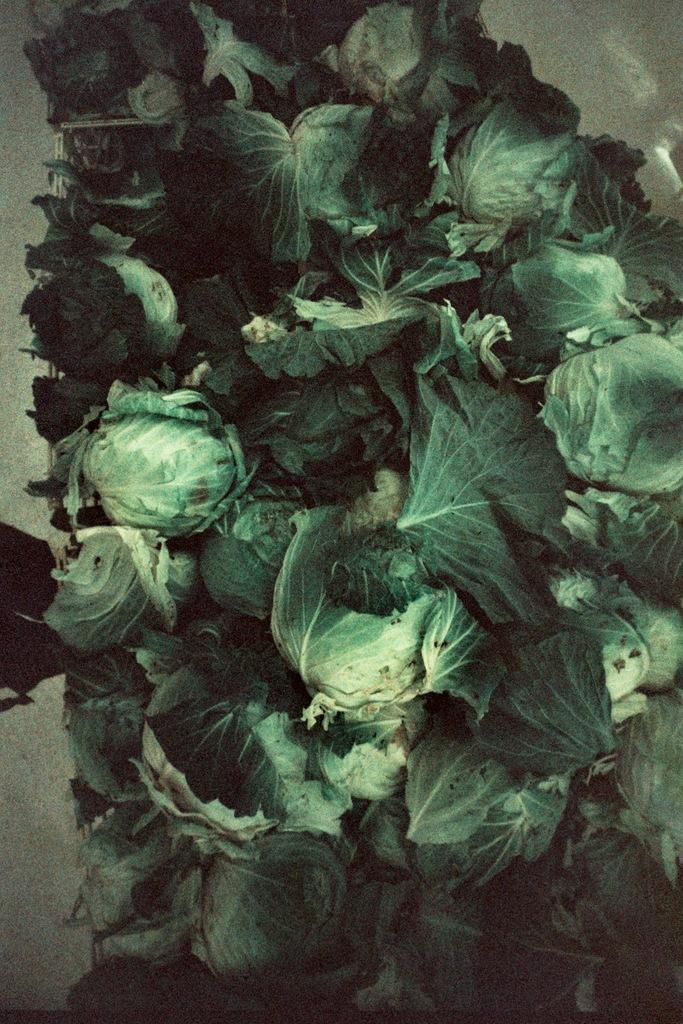What type of vegetable is present in the image? There are cauliflowers in the image. Where are the cauliflowers located? The cauliflowers are on an object. What type of quartz can be seen near the cauliflowers in the image? There is no quartz present in the image. Can you see a lake in the background of the image? There is no lake visible in the image. 